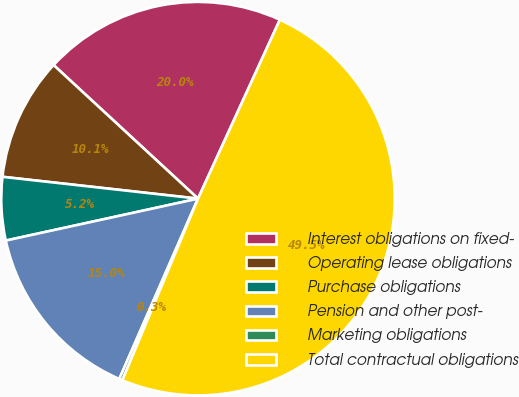<chart> <loc_0><loc_0><loc_500><loc_500><pie_chart><fcel>Interest obligations on fixed-<fcel>Operating lease obligations<fcel>Purchase obligations<fcel>Pension and other post-<fcel>Marketing obligations<fcel>Total contractual obligations<nl><fcel>19.95%<fcel>10.11%<fcel>5.19%<fcel>15.03%<fcel>0.27%<fcel>49.45%<nl></chart> 